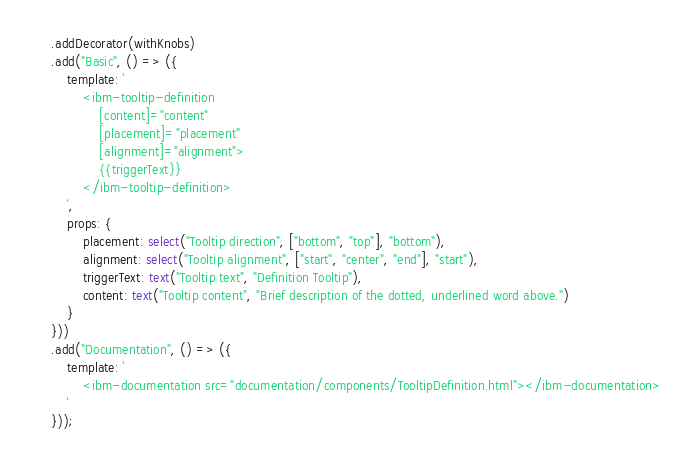Convert code to text. <code><loc_0><loc_0><loc_500><loc_500><_TypeScript_>	.addDecorator(withKnobs)
	.add("Basic", () => ({
		template: `
			<ibm-tooltip-definition
				[content]="content"
				[placement]="placement"
				[alignment]="alignment">
				{{triggerText}}
			</ibm-tooltip-definition>
		`,
		props: {
			placement: select("Tooltip direction", ["bottom", "top"], "bottom"),
			alignment: select("Tooltip alignment", ["start", "center", "end"], "start"),
			triggerText: text("Tooltip text", "Definition Tooltip"),
			content: text("Tooltip content", "Brief description of the dotted, underlined word above.")
		}
	}))
	.add("Documentation", () => ({
		template: `
			<ibm-documentation src="documentation/components/TooltipDefinition.html"></ibm-documentation>
		`
	}));
</code> 